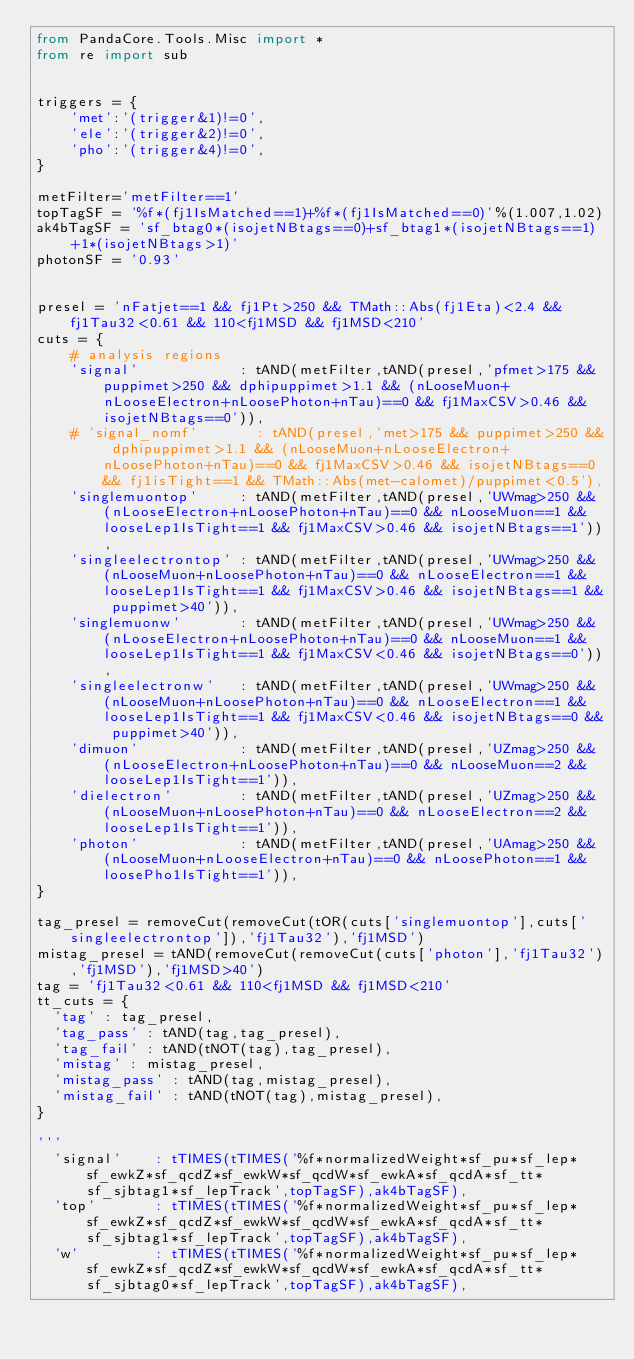<code> <loc_0><loc_0><loc_500><loc_500><_Python_>from PandaCore.Tools.Misc import *
from re import sub


triggers = {
    'met':'(trigger&1)!=0',
    'ele':'(trigger&2)!=0',
    'pho':'(trigger&4)!=0',
}

metFilter='metFilter==1'
topTagSF = '%f*(fj1IsMatched==1)+%f*(fj1IsMatched==0)'%(1.007,1.02)
ak4bTagSF = 'sf_btag0*(isojetNBtags==0)+sf_btag1*(isojetNBtags==1)+1*(isojetNBtags>1)'
photonSF = '0.93'


presel = 'nFatjet==1 && fj1Pt>250 && TMath::Abs(fj1Eta)<2.4 && fj1Tau32<0.61 && 110<fj1MSD && fj1MSD<210'
cuts = {
    # analysis regions
    'signal'            : tAND(metFilter,tAND(presel,'pfmet>175 && puppimet>250 && dphipuppimet>1.1 && (nLooseMuon+nLooseElectron+nLoosePhoton+nTau)==0 && fj1MaxCSV>0.46 && isojetNBtags==0')),
    # 'signal_nomf'       : tAND(presel,'met>175 && puppimet>250 && dphipuppimet>1.1 && (nLooseMuon+nLooseElectron+nLoosePhoton+nTau)==0 && fj1MaxCSV>0.46 && isojetNBtags==0 && fj1isTight==1 && TMath::Abs(met-calomet)/puppimet<0.5'),
    'singlemuontop'     : tAND(metFilter,tAND(presel,'UWmag>250 && (nLooseElectron+nLoosePhoton+nTau)==0 && nLooseMuon==1 && looseLep1IsTight==1 && fj1MaxCSV>0.46 && isojetNBtags==1')),
    'singleelectrontop' : tAND(metFilter,tAND(presel,'UWmag>250 && (nLooseMuon+nLoosePhoton+nTau)==0 && nLooseElectron==1 && looseLep1IsTight==1 && fj1MaxCSV>0.46 && isojetNBtags==1 && puppimet>40')),
    'singlemuonw'       : tAND(metFilter,tAND(presel,'UWmag>250 && (nLooseElectron+nLoosePhoton+nTau)==0 && nLooseMuon==1 && looseLep1IsTight==1 && fj1MaxCSV<0.46 && isojetNBtags==0')),
    'singleelectronw'   : tAND(metFilter,tAND(presel,'UWmag>250 && (nLooseMuon+nLoosePhoton+nTau)==0 && nLooseElectron==1 && looseLep1IsTight==1 && fj1MaxCSV<0.46 && isojetNBtags==0 && puppimet>40')),
    'dimuon'            : tAND(metFilter,tAND(presel,'UZmag>250 && (nLooseElectron+nLoosePhoton+nTau)==0 && nLooseMuon==2 && looseLep1IsTight==1')),
    'dielectron'        : tAND(metFilter,tAND(presel,'UZmag>250 && (nLooseMuon+nLoosePhoton+nTau)==0 && nLooseElectron==2 && looseLep1IsTight==1')),
    'photon'            : tAND(metFilter,tAND(presel,'UAmag>250 && (nLooseMuon+nLooseElectron+nTau)==0 && nLoosePhoton==1 && loosePho1IsTight==1')),
}

tag_presel = removeCut(removeCut(tOR(cuts['singlemuontop'],cuts['singleelectrontop']),'fj1Tau32'),'fj1MSD')
mistag_presel = tAND(removeCut(removeCut(cuts['photon'],'fj1Tau32'),'fj1MSD'),'fj1MSD>40')
tag = 'fj1Tau32<0.61 && 110<fj1MSD && fj1MSD<210'
tt_cuts = {
  'tag' : tag_presel,
  'tag_pass' : tAND(tag,tag_presel),
  'tag_fail' : tAND(tNOT(tag),tag_presel),
  'mistag' : mistag_presel,
  'mistag_pass' : tAND(tag,mistag_presel),
  'mistag_fail' : tAND(tNOT(tag),mistag_presel),
}

'''
  'signal'    : tTIMES(tTIMES('%f*normalizedWeight*sf_pu*sf_lep*sf_ewkZ*sf_qcdZ*sf_ewkW*sf_qcdW*sf_ewkA*sf_qcdA*sf_tt*sf_sjbtag1*sf_lepTrack',topTagSF),ak4bTagSF),
  'top'       : tTIMES(tTIMES('%f*normalizedWeight*sf_pu*sf_lep*sf_ewkZ*sf_qcdZ*sf_ewkW*sf_qcdW*sf_ewkA*sf_qcdA*sf_tt*sf_sjbtag1*sf_lepTrack',topTagSF),ak4bTagSF),
  'w'         : tTIMES(tTIMES('%f*normalizedWeight*sf_pu*sf_lep*sf_ewkZ*sf_qcdZ*sf_ewkW*sf_qcdW*sf_ewkA*sf_qcdA*sf_tt*sf_sjbtag0*sf_lepTrack',topTagSF),ak4bTagSF),</code> 